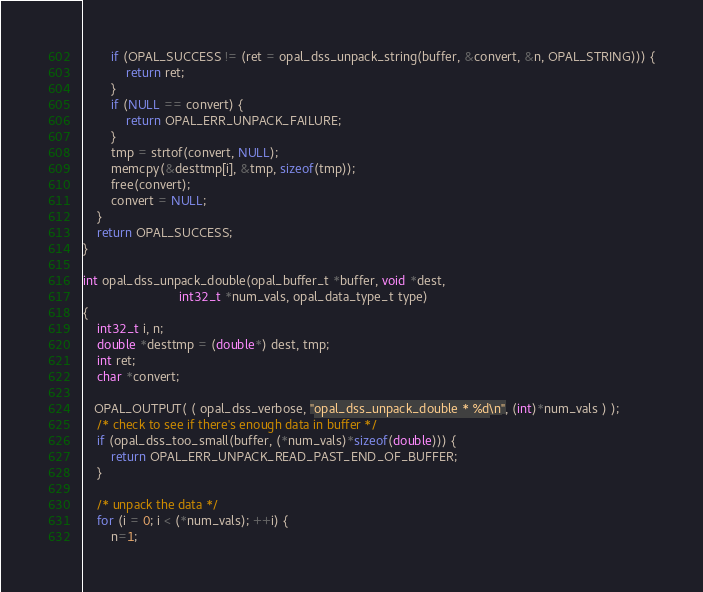Convert code to text. <code><loc_0><loc_0><loc_500><loc_500><_C_>        if (OPAL_SUCCESS != (ret = opal_dss_unpack_string(buffer, &convert, &n, OPAL_STRING))) {
            return ret;
        }
        if (NULL == convert) {
            return OPAL_ERR_UNPACK_FAILURE;
        }
        tmp = strtof(convert, NULL);
        memcpy(&desttmp[i], &tmp, sizeof(tmp));
        free(convert);
        convert = NULL;
    }
    return OPAL_SUCCESS;
}

int opal_dss_unpack_double(opal_buffer_t *buffer, void *dest,
                           int32_t *num_vals, opal_data_type_t type)
{
    int32_t i, n;
    double *desttmp = (double*) dest, tmp;
    int ret;
    char *convert;

   OPAL_OUTPUT( ( opal_dss_verbose, "opal_dss_unpack_double * %d\n", (int)*num_vals ) );
    /* check to see if there's enough data in buffer */
    if (opal_dss_too_small(buffer, (*num_vals)*sizeof(double))) {
        return OPAL_ERR_UNPACK_READ_PAST_END_OF_BUFFER;
    }

    /* unpack the data */
    for (i = 0; i < (*num_vals); ++i) {
        n=1;</code> 